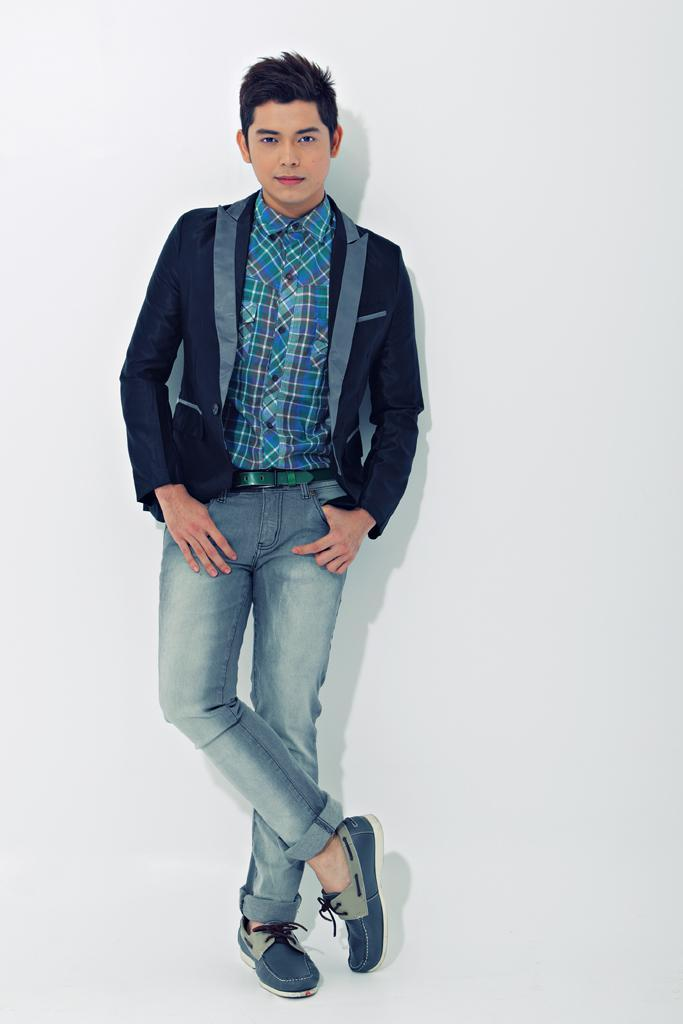What is the main subject of the image? There is a person in the image. Can you describe the position of the person in the image? The person is standing in the center of the image. What is the person doing in the image? The person is posing for the picture. What type of pen can be seen in the image? There is no pen present in the image. How many ladybugs are visible on the person's clothing in the image? There are no ladybugs visible on the person's clothing in the image. 